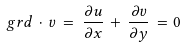Convert formula to latex. <formula><loc_0><loc_0><loc_500><loc_500>\ g r d \, \cdot \, { v } \, = \, \frac { \partial { u } } { \partial x } \, + \, \frac { \partial { v } } { \partial y } \, = 0</formula> 